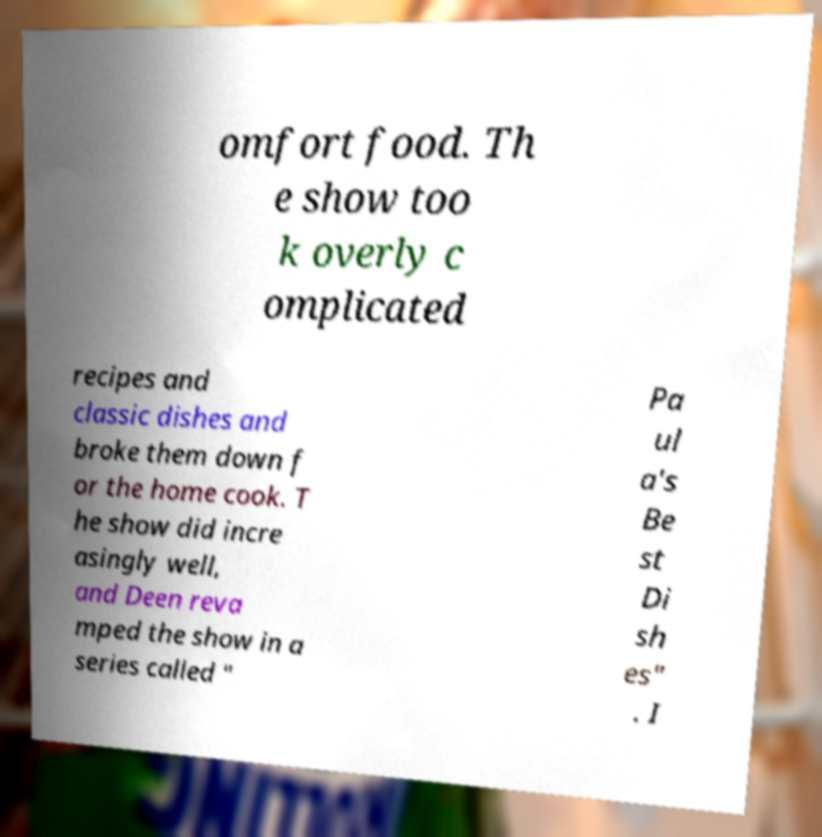For documentation purposes, I need the text within this image transcribed. Could you provide that? omfort food. Th e show too k overly c omplicated recipes and classic dishes and broke them down f or the home cook. T he show did incre asingly well, and Deen reva mped the show in a series called " Pa ul a's Be st Di sh es" . I 